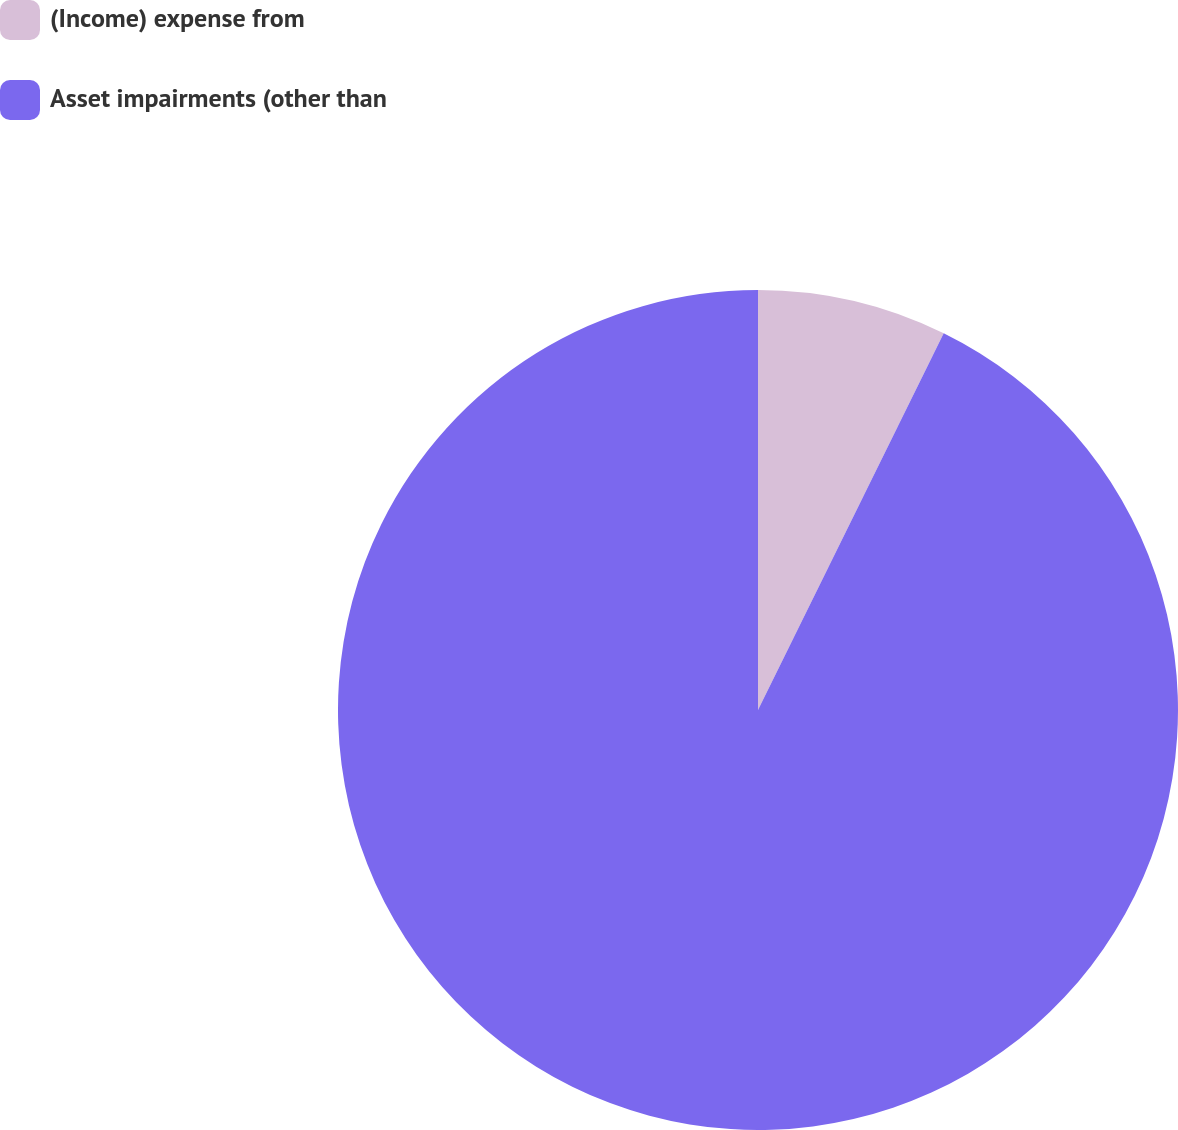Convert chart to OTSL. <chart><loc_0><loc_0><loc_500><loc_500><pie_chart><fcel>(Income) expense from<fcel>Asset impairments (other than<nl><fcel>7.29%<fcel>92.71%<nl></chart> 